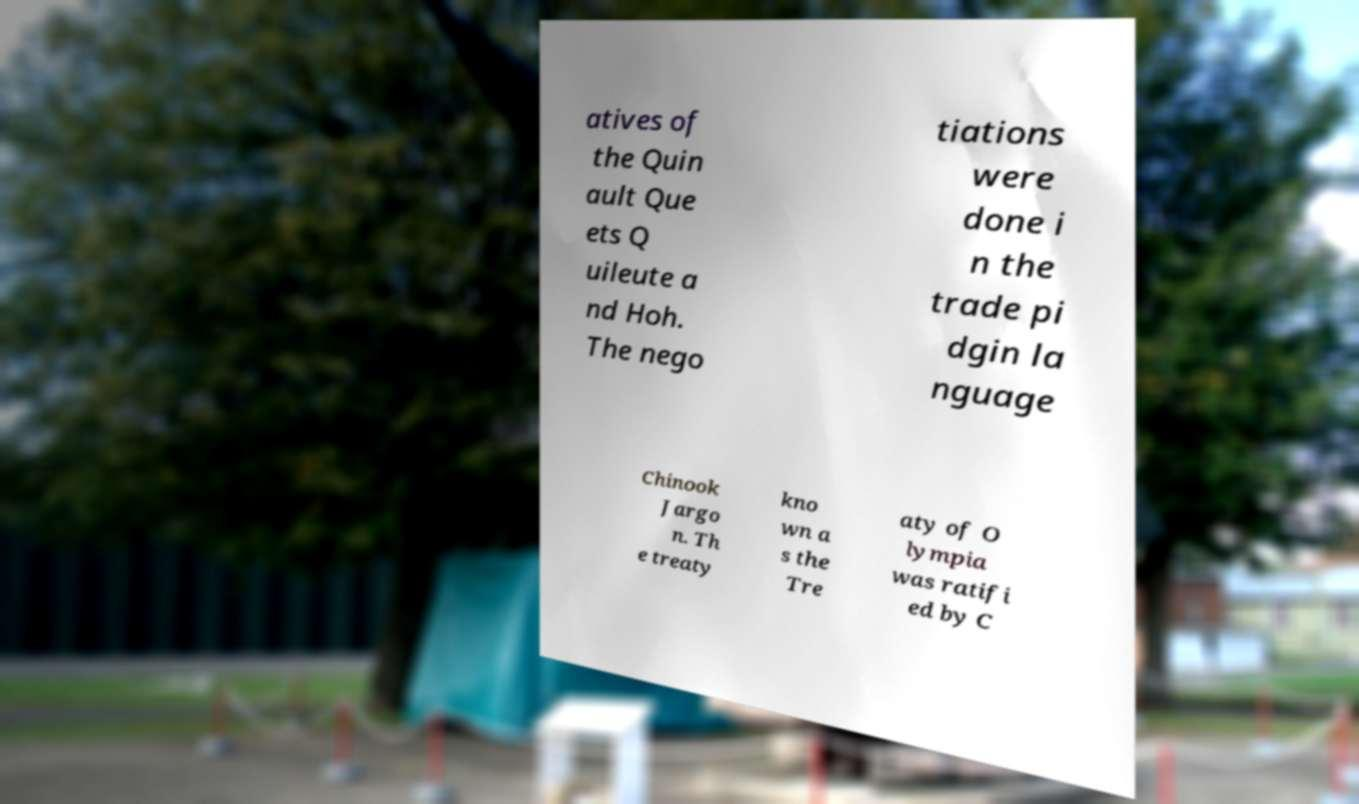What messages or text are displayed in this image? I need them in a readable, typed format. atives of the Quin ault Que ets Q uileute a nd Hoh. The nego tiations were done i n the trade pi dgin la nguage Chinook Jargo n. Th e treaty kno wn a s the Tre aty of O lympia was ratifi ed by C 